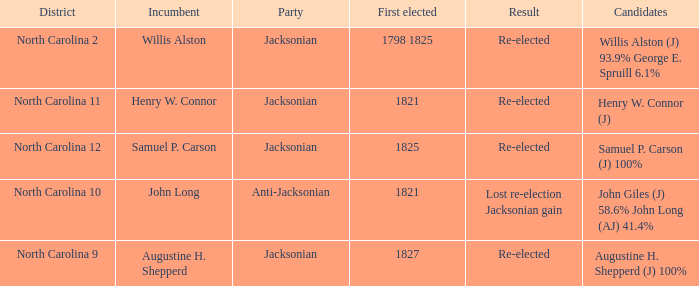What is the outcome for augustine h. shepperd (j) with 100%? Re-elected. 